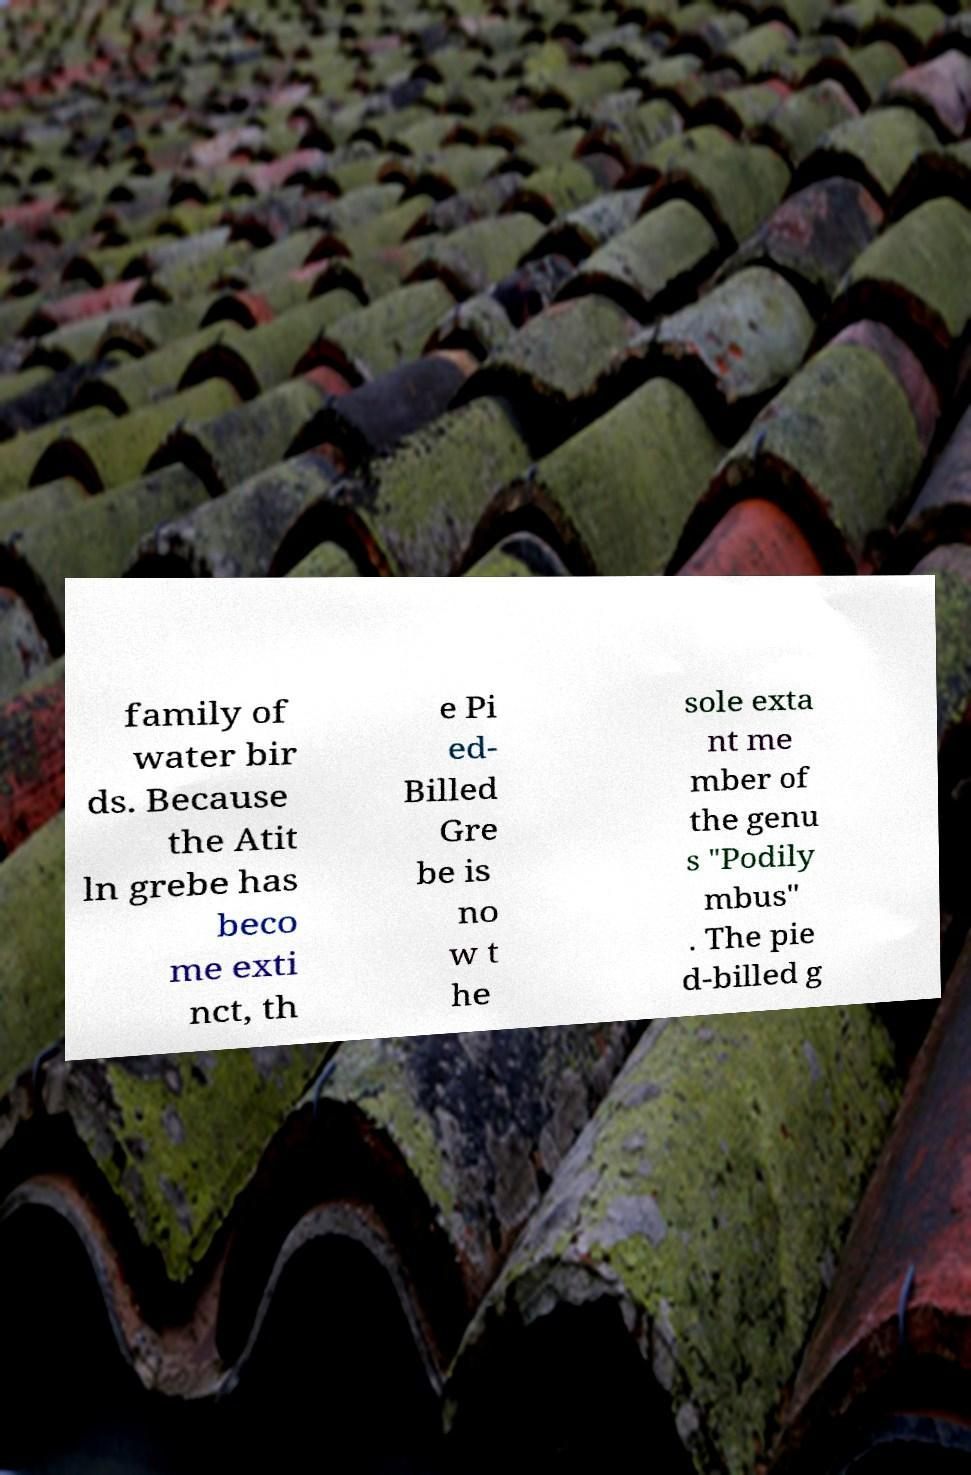For documentation purposes, I need the text within this image transcribed. Could you provide that? family of water bir ds. Because the Atit ln grebe has beco me exti nct, th e Pi ed- Billed Gre be is no w t he sole exta nt me mber of the genu s "Podily mbus" . The pie d-billed g 